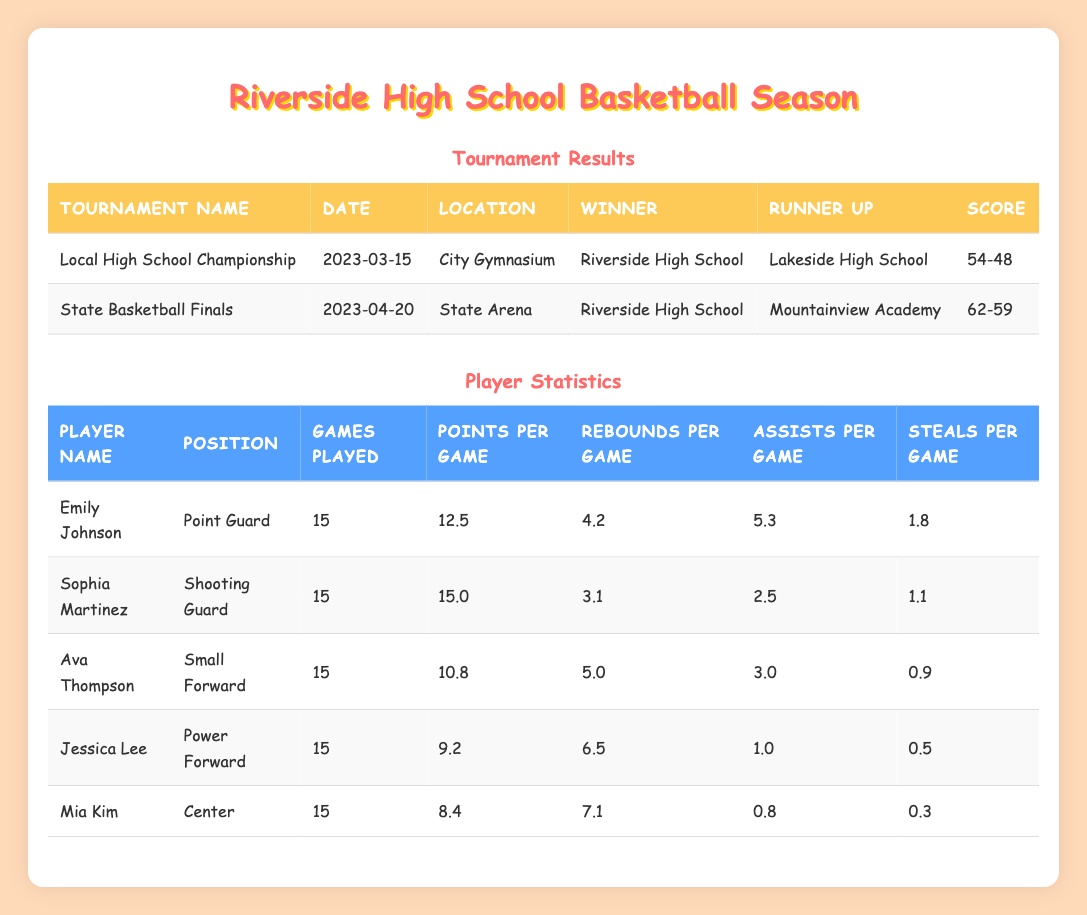What was the score in the State Basketball Finals? The score in the State Basketball Finals is listed directly in the table under the "Score" column for the corresponding tournament, which is 62-59.
Answer: 62-59 Who was the runner-up in the Local High School Championship? The runner-up for this tournament is specified in the "Runner Up" column, which shows Lakeside High School as the runner-up in the Local High School Championship.
Answer: Lakeside High School How many points per game did Emily Johnson score? Emily Johnson's points per game can be found in the "Points per Game" column under her name in the player statistics table, which shows that she scored 12.5 points per game.
Answer: 12.5 What is the total number of rebounds per game for all players? To find the total rebounds per game, I will add up the rebounds from the "Rebounds per Game" column for each player: 4.2 (Emily) + 3.1 (Sophia) + 5.0 (Ava) + 6.5 (Jessica) + 7.1 (Mia) = 26.9 total rebounds per game.
Answer: 26.9 Did Mia Kim have more or less than 10 points per game? Looking at the points per game for Mia Kim in the "Points per Game" column, she scored 8.4 points per game, which is less than 10.
Answer: Less than 10 Which player had the highest assists per game and what was the number? By checking the "Assists per Game" column, I see that Emily Johnson had the highest assists per game with 5.3.
Answer: 5.3 What is the average points per game for all players? To calculate the average points per game, I add the points per game for each player (12.5 + 15.0 + 10.8 + 9.2 + 8.4 = 55.9) and divide by the number of players (5). The average is 55.9 / 5 = 11.18.
Answer: 11.18 Was Riverside High School the winner in both tournaments? Riverside High School is listed as the winner in both tournaments in the "Winner" column for the Local High School Championship and the State Basketball Finals. Therefore, the answer is yes.
Answer: Yes How many games did Jessica Lee play, and what was her average rebounds per game? Jessica Lee's number of games played is listed in the "Games Played" column as 15, and her average rebounds per game is shown in the "Rebounds per Game" column as 6.5.
Answer: 15 games, 6.5 rebounds per game 